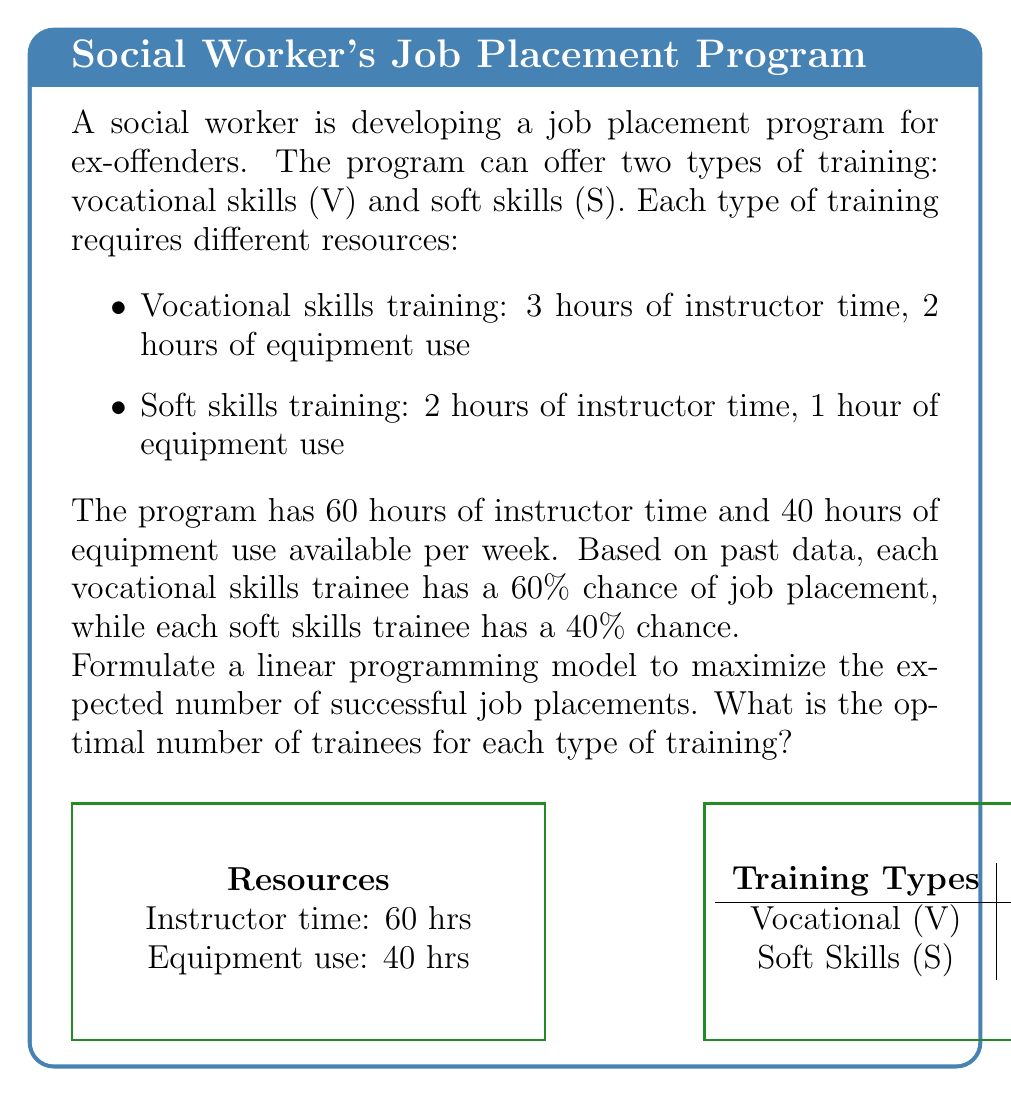Give your solution to this math problem. Let's solve this step-by-step:

1) Define variables:
   Let $x$ = number of vocational skills trainees
   Let $y$ = number of soft skills trainees

2) Objective function:
   Maximize $Z = 0.6x + 0.4y$ (expected successful placements)

3) Constraints:
   Instructor time: $3x + 2y \leq 60$
   Equipment use: $2x + y \leq 40$
   Non-negativity: $x \geq 0, y \geq 0$

4) The linear programming model:

   Maximize $Z = 0.6x + 0.4y$
   Subject to:
   $3x + 2y \leq 60$
   $2x + y \leq 40$
   $x, y \geq 0$

5) Solve using the graphical method:

   Plot the constraints:
   $3x + 2y = 60$ intersects at (20,0) and (0,30)
   $2x + y = 40$ intersects at (20,0) and (0,40)

6) The feasible region is bounded by these lines and the axes.

7) The corners of the feasible region are (0,0), (0,30), (10,20), and (20,0).

8) Evaluate the objective function at each corner:
   (0,0): Z = 0
   (0,30): Z = 12
   (10,20): Z = 14
   (20,0): Z = 12

9) The maximum value occurs at (10,20).

Therefore, the optimal solution is to train 10 people in vocational skills and 20 people in soft skills.
Answer: 10 vocational skills trainees, 20 soft skills trainees 